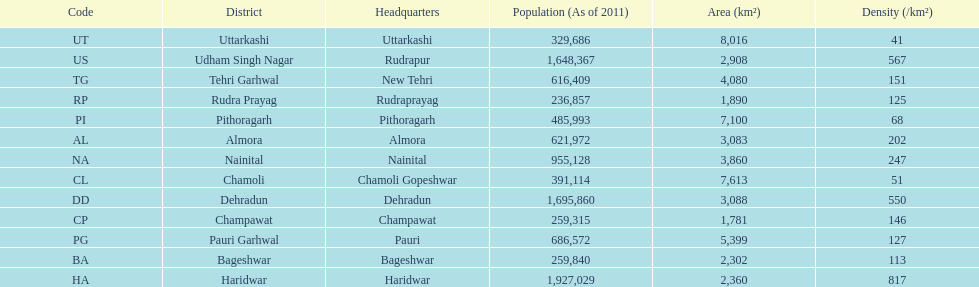What is the last code listed? UT. 